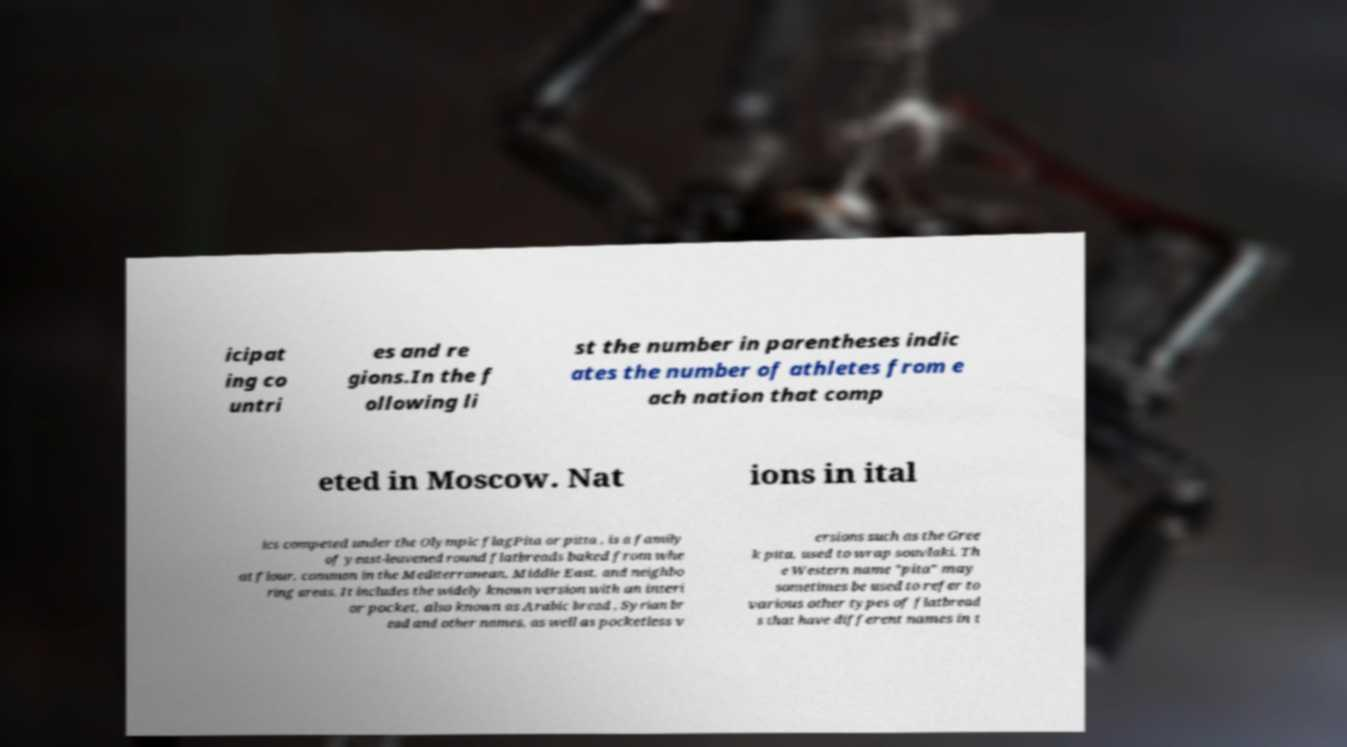Can you accurately transcribe the text from the provided image for me? icipat ing co untri es and re gions.In the f ollowing li st the number in parentheses indic ates the number of athletes from e ach nation that comp eted in Moscow. Nat ions in ital ics competed under the Olympic flagPita or pitta , is a family of yeast-leavened round flatbreads baked from whe at flour, common in the Mediterranean, Middle East, and neighbo ring areas. It includes the widely known version with an interi or pocket, also known as Arabic bread , Syrian br ead and other names, as well as pocketless v ersions such as the Gree k pita, used to wrap souvlaki. Th e Western name "pita" may sometimes be used to refer to various other types of flatbread s that have different names in t 